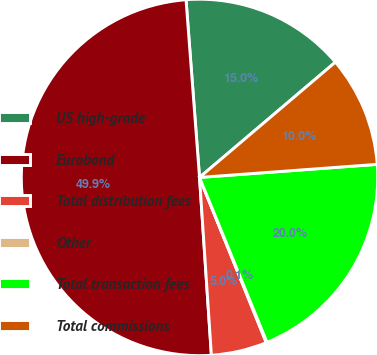Convert chart to OTSL. <chart><loc_0><loc_0><loc_500><loc_500><pie_chart><fcel>US high-grade<fcel>Eurobond<fcel>Total distribution fees<fcel>Other<fcel>Total transaction fees<fcel>Total commissions<nl><fcel>15.01%<fcel>49.86%<fcel>5.05%<fcel>0.07%<fcel>19.99%<fcel>10.03%<nl></chart> 